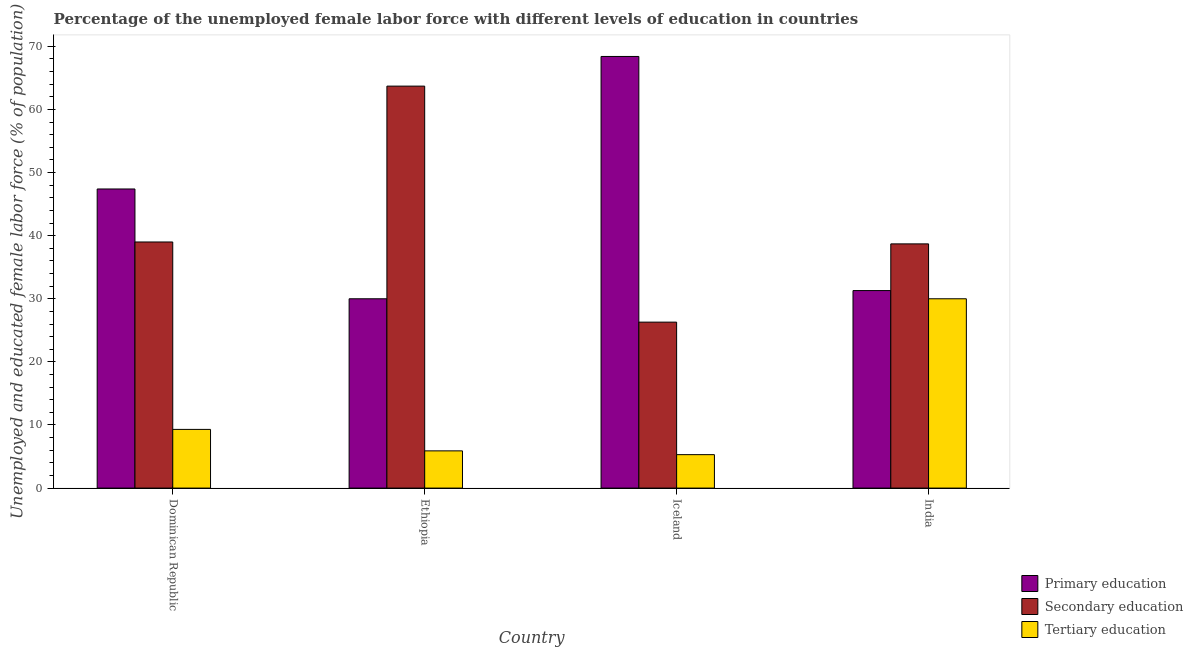Are the number of bars per tick equal to the number of legend labels?
Keep it short and to the point. Yes. What is the percentage of female labor force who received tertiary education in Dominican Republic?
Your answer should be compact. 9.3. Across all countries, what is the maximum percentage of female labor force who received primary education?
Provide a short and direct response. 68.4. Across all countries, what is the minimum percentage of female labor force who received secondary education?
Keep it short and to the point. 26.3. In which country was the percentage of female labor force who received secondary education minimum?
Your response must be concise. Iceland. What is the total percentage of female labor force who received secondary education in the graph?
Offer a terse response. 167.7. What is the difference between the percentage of female labor force who received tertiary education in Dominican Republic and that in Ethiopia?
Give a very brief answer. 3.4. What is the average percentage of female labor force who received secondary education per country?
Provide a succinct answer. 41.93. What is the difference between the percentage of female labor force who received tertiary education and percentage of female labor force who received secondary education in Ethiopia?
Offer a very short reply. -57.8. In how many countries, is the percentage of female labor force who received tertiary education greater than 66 %?
Keep it short and to the point. 0. What is the ratio of the percentage of female labor force who received tertiary education in Ethiopia to that in India?
Provide a succinct answer. 0.2. Is the percentage of female labor force who received primary education in Dominican Republic less than that in Ethiopia?
Provide a short and direct response. No. Is the difference between the percentage of female labor force who received tertiary education in Dominican Republic and Iceland greater than the difference between the percentage of female labor force who received secondary education in Dominican Republic and Iceland?
Your answer should be compact. No. What is the difference between the highest and the second highest percentage of female labor force who received tertiary education?
Provide a succinct answer. 20.7. What is the difference between the highest and the lowest percentage of female labor force who received secondary education?
Your answer should be very brief. 37.4. In how many countries, is the percentage of female labor force who received tertiary education greater than the average percentage of female labor force who received tertiary education taken over all countries?
Your answer should be very brief. 1. Is the sum of the percentage of female labor force who received tertiary education in Dominican Republic and Ethiopia greater than the maximum percentage of female labor force who received primary education across all countries?
Provide a short and direct response. No. What does the 2nd bar from the right in Dominican Republic represents?
Offer a very short reply. Secondary education. Is it the case that in every country, the sum of the percentage of female labor force who received primary education and percentage of female labor force who received secondary education is greater than the percentage of female labor force who received tertiary education?
Offer a terse response. Yes. How many countries are there in the graph?
Provide a short and direct response. 4. What is the difference between two consecutive major ticks on the Y-axis?
Offer a terse response. 10. Are the values on the major ticks of Y-axis written in scientific E-notation?
Your answer should be very brief. No. Does the graph contain grids?
Keep it short and to the point. No. How many legend labels are there?
Give a very brief answer. 3. What is the title of the graph?
Ensure brevity in your answer.  Percentage of the unemployed female labor force with different levels of education in countries. Does "Textiles and clothing" appear as one of the legend labels in the graph?
Your answer should be compact. No. What is the label or title of the X-axis?
Give a very brief answer. Country. What is the label or title of the Y-axis?
Offer a very short reply. Unemployed and educated female labor force (% of population). What is the Unemployed and educated female labor force (% of population) in Primary education in Dominican Republic?
Your answer should be compact. 47.4. What is the Unemployed and educated female labor force (% of population) in Tertiary education in Dominican Republic?
Offer a very short reply. 9.3. What is the Unemployed and educated female labor force (% of population) of Primary education in Ethiopia?
Provide a succinct answer. 30. What is the Unemployed and educated female labor force (% of population) of Secondary education in Ethiopia?
Give a very brief answer. 63.7. What is the Unemployed and educated female labor force (% of population) in Tertiary education in Ethiopia?
Your answer should be compact. 5.9. What is the Unemployed and educated female labor force (% of population) in Primary education in Iceland?
Make the answer very short. 68.4. What is the Unemployed and educated female labor force (% of population) of Secondary education in Iceland?
Give a very brief answer. 26.3. What is the Unemployed and educated female labor force (% of population) of Tertiary education in Iceland?
Provide a succinct answer. 5.3. What is the Unemployed and educated female labor force (% of population) in Primary education in India?
Ensure brevity in your answer.  31.3. What is the Unemployed and educated female labor force (% of population) of Secondary education in India?
Offer a terse response. 38.7. Across all countries, what is the maximum Unemployed and educated female labor force (% of population) in Primary education?
Your response must be concise. 68.4. Across all countries, what is the maximum Unemployed and educated female labor force (% of population) in Secondary education?
Your answer should be very brief. 63.7. Across all countries, what is the minimum Unemployed and educated female labor force (% of population) in Secondary education?
Ensure brevity in your answer.  26.3. Across all countries, what is the minimum Unemployed and educated female labor force (% of population) in Tertiary education?
Your answer should be compact. 5.3. What is the total Unemployed and educated female labor force (% of population) of Primary education in the graph?
Your answer should be very brief. 177.1. What is the total Unemployed and educated female labor force (% of population) in Secondary education in the graph?
Offer a terse response. 167.7. What is the total Unemployed and educated female labor force (% of population) of Tertiary education in the graph?
Provide a short and direct response. 50.5. What is the difference between the Unemployed and educated female labor force (% of population) in Primary education in Dominican Republic and that in Ethiopia?
Keep it short and to the point. 17.4. What is the difference between the Unemployed and educated female labor force (% of population) in Secondary education in Dominican Republic and that in Ethiopia?
Provide a succinct answer. -24.7. What is the difference between the Unemployed and educated female labor force (% of population) of Tertiary education in Dominican Republic and that in Ethiopia?
Offer a terse response. 3.4. What is the difference between the Unemployed and educated female labor force (% of population) in Primary education in Dominican Republic and that in Iceland?
Offer a very short reply. -21. What is the difference between the Unemployed and educated female labor force (% of population) in Secondary education in Dominican Republic and that in Iceland?
Offer a terse response. 12.7. What is the difference between the Unemployed and educated female labor force (% of population) in Tertiary education in Dominican Republic and that in Iceland?
Make the answer very short. 4. What is the difference between the Unemployed and educated female labor force (% of population) of Primary education in Dominican Republic and that in India?
Offer a very short reply. 16.1. What is the difference between the Unemployed and educated female labor force (% of population) of Tertiary education in Dominican Republic and that in India?
Provide a short and direct response. -20.7. What is the difference between the Unemployed and educated female labor force (% of population) in Primary education in Ethiopia and that in Iceland?
Offer a very short reply. -38.4. What is the difference between the Unemployed and educated female labor force (% of population) of Secondary education in Ethiopia and that in Iceland?
Ensure brevity in your answer.  37.4. What is the difference between the Unemployed and educated female labor force (% of population) of Tertiary education in Ethiopia and that in India?
Offer a very short reply. -24.1. What is the difference between the Unemployed and educated female labor force (% of population) in Primary education in Iceland and that in India?
Your answer should be very brief. 37.1. What is the difference between the Unemployed and educated female labor force (% of population) of Secondary education in Iceland and that in India?
Provide a short and direct response. -12.4. What is the difference between the Unemployed and educated female labor force (% of population) of Tertiary education in Iceland and that in India?
Offer a very short reply. -24.7. What is the difference between the Unemployed and educated female labor force (% of population) of Primary education in Dominican Republic and the Unemployed and educated female labor force (% of population) of Secondary education in Ethiopia?
Offer a terse response. -16.3. What is the difference between the Unemployed and educated female labor force (% of population) in Primary education in Dominican Republic and the Unemployed and educated female labor force (% of population) in Tertiary education in Ethiopia?
Provide a short and direct response. 41.5. What is the difference between the Unemployed and educated female labor force (% of population) in Secondary education in Dominican Republic and the Unemployed and educated female labor force (% of population) in Tertiary education in Ethiopia?
Your answer should be very brief. 33.1. What is the difference between the Unemployed and educated female labor force (% of population) of Primary education in Dominican Republic and the Unemployed and educated female labor force (% of population) of Secondary education in Iceland?
Your answer should be compact. 21.1. What is the difference between the Unemployed and educated female labor force (% of population) in Primary education in Dominican Republic and the Unemployed and educated female labor force (% of population) in Tertiary education in Iceland?
Offer a very short reply. 42.1. What is the difference between the Unemployed and educated female labor force (% of population) of Secondary education in Dominican Republic and the Unemployed and educated female labor force (% of population) of Tertiary education in Iceland?
Keep it short and to the point. 33.7. What is the difference between the Unemployed and educated female labor force (% of population) in Primary education in Dominican Republic and the Unemployed and educated female labor force (% of population) in Secondary education in India?
Ensure brevity in your answer.  8.7. What is the difference between the Unemployed and educated female labor force (% of population) of Primary education in Ethiopia and the Unemployed and educated female labor force (% of population) of Tertiary education in Iceland?
Your response must be concise. 24.7. What is the difference between the Unemployed and educated female labor force (% of population) in Secondary education in Ethiopia and the Unemployed and educated female labor force (% of population) in Tertiary education in Iceland?
Ensure brevity in your answer.  58.4. What is the difference between the Unemployed and educated female labor force (% of population) in Primary education in Ethiopia and the Unemployed and educated female labor force (% of population) in Secondary education in India?
Give a very brief answer. -8.7. What is the difference between the Unemployed and educated female labor force (% of population) of Primary education in Ethiopia and the Unemployed and educated female labor force (% of population) of Tertiary education in India?
Make the answer very short. 0. What is the difference between the Unemployed and educated female labor force (% of population) in Secondary education in Ethiopia and the Unemployed and educated female labor force (% of population) in Tertiary education in India?
Ensure brevity in your answer.  33.7. What is the difference between the Unemployed and educated female labor force (% of population) in Primary education in Iceland and the Unemployed and educated female labor force (% of population) in Secondary education in India?
Ensure brevity in your answer.  29.7. What is the difference between the Unemployed and educated female labor force (% of population) in Primary education in Iceland and the Unemployed and educated female labor force (% of population) in Tertiary education in India?
Your response must be concise. 38.4. What is the average Unemployed and educated female labor force (% of population) of Primary education per country?
Your answer should be compact. 44.27. What is the average Unemployed and educated female labor force (% of population) in Secondary education per country?
Your answer should be very brief. 41.92. What is the average Unemployed and educated female labor force (% of population) of Tertiary education per country?
Ensure brevity in your answer.  12.62. What is the difference between the Unemployed and educated female labor force (% of population) in Primary education and Unemployed and educated female labor force (% of population) in Secondary education in Dominican Republic?
Your answer should be very brief. 8.4. What is the difference between the Unemployed and educated female labor force (% of population) in Primary education and Unemployed and educated female labor force (% of population) in Tertiary education in Dominican Republic?
Your answer should be very brief. 38.1. What is the difference between the Unemployed and educated female labor force (% of population) of Secondary education and Unemployed and educated female labor force (% of population) of Tertiary education in Dominican Republic?
Keep it short and to the point. 29.7. What is the difference between the Unemployed and educated female labor force (% of population) in Primary education and Unemployed and educated female labor force (% of population) in Secondary education in Ethiopia?
Offer a terse response. -33.7. What is the difference between the Unemployed and educated female labor force (% of population) of Primary education and Unemployed and educated female labor force (% of population) of Tertiary education in Ethiopia?
Your answer should be compact. 24.1. What is the difference between the Unemployed and educated female labor force (% of population) in Secondary education and Unemployed and educated female labor force (% of population) in Tertiary education in Ethiopia?
Provide a succinct answer. 57.8. What is the difference between the Unemployed and educated female labor force (% of population) of Primary education and Unemployed and educated female labor force (% of population) of Secondary education in Iceland?
Ensure brevity in your answer.  42.1. What is the difference between the Unemployed and educated female labor force (% of population) of Primary education and Unemployed and educated female labor force (% of population) of Tertiary education in Iceland?
Ensure brevity in your answer.  63.1. What is the difference between the Unemployed and educated female labor force (% of population) of Primary education and Unemployed and educated female labor force (% of population) of Secondary education in India?
Keep it short and to the point. -7.4. What is the difference between the Unemployed and educated female labor force (% of population) of Secondary education and Unemployed and educated female labor force (% of population) of Tertiary education in India?
Offer a terse response. 8.7. What is the ratio of the Unemployed and educated female labor force (% of population) of Primary education in Dominican Republic to that in Ethiopia?
Offer a terse response. 1.58. What is the ratio of the Unemployed and educated female labor force (% of population) in Secondary education in Dominican Republic to that in Ethiopia?
Make the answer very short. 0.61. What is the ratio of the Unemployed and educated female labor force (% of population) in Tertiary education in Dominican Republic to that in Ethiopia?
Provide a succinct answer. 1.58. What is the ratio of the Unemployed and educated female labor force (% of population) of Primary education in Dominican Republic to that in Iceland?
Offer a terse response. 0.69. What is the ratio of the Unemployed and educated female labor force (% of population) in Secondary education in Dominican Republic to that in Iceland?
Ensure brevity in your answer.  1.48. What is the ratio of the Unemployed and educated female labor force (% of population) of Tertiary education in Dominican Republic to that in Iceland?
Your answer should be compact. 1.75. What is the ratio of the Unemployed and educated female labor force (% of population) in Primary education in Dominican Republic to that in India?
Offer a terse response. 1.51. What is the ratio of the Unemployed and educated female labor force (% of population) in Secondary education in Dominican Republic to that in India?
Your response must be concise. 1.01. What is the ratio of the Unemployed and educated female labor force (% of population) of Tertiary education in Dominican Republic to that in India?
Offer a very short reply. 0.31. What is the ratio of the Unemployed and educated female labor force (% of population) in Primary education in Ethiopia to that in Iceland?
Offer a terse response. 0.44. What is the ratio of the Unemployed and educated female labor force (% of population) in Secondary education in Ethiopia to that in Iceland?
Keep it short and to the point. 2.42. What is the ratio of the Unemployed and educated female labor force (% of population) in Tertiary education in Ethiopia to that in Iceland?
Offer a very short reply. 1.11. What is the ratio of the Unemployed and educated female labor force (% of population) in Primary education in Ethiopia to that in India?
Your answer should be compact. 0.96. What is the ratio of the Unemployed and educated female labor force (% of population) in Secondary education in Ethiopia to that in India?
Provide a short and direct response. 1.65. What is the ratio of the Unemployed and educated female labor force (% of population) of Tertiary education in Ethiopia to that in India?
Provide a short and direct response. 0.2. What is the ratio of the Unemployed and educated female labor force (% of population) of Primary education in Iceland to that in India?
Ensure brevity in your answer.  2.19. What is the ratio of the Unemployed and educated female labor force (% of population) in Secondary education in Iceland to that in India?
Ensure brevity in your answer.  0.68. What is the ratio of the Unemployed and educated female labor force (% of population) in Tertiary education in Iceland to that in India?
Ensure brevity in your answer.  0.18. What is the difference between the highest and the second highest Unemployed and educated female labor force (% of population) in Primary education?
Make the answer very short. 21. What is the difference between the highest and the second highest Unemployed and educated female labor force (% of population) of Secondary education?
Give a very brief answer. 24.7. What is the difference between the highest and the second highest Unemployed and educated female labor force (% of population) of Tertiary education?
Provide a succinct answer. 20.7. What is the difference between the highest and the lowest Unemployed and educated female labor force (% of population) of Primary education?
Offer a terse response. 38.4. What is the difference between the highest and the lowest Unemployed and educated female labor force (% of population) in Secondary education?
Provide a short and direct response. 37.4. What is the difference between the highest and the lowest Unemployed and educated female labor force (% of population) in Tertiary education?
Your answer should be compact. 24.7. 